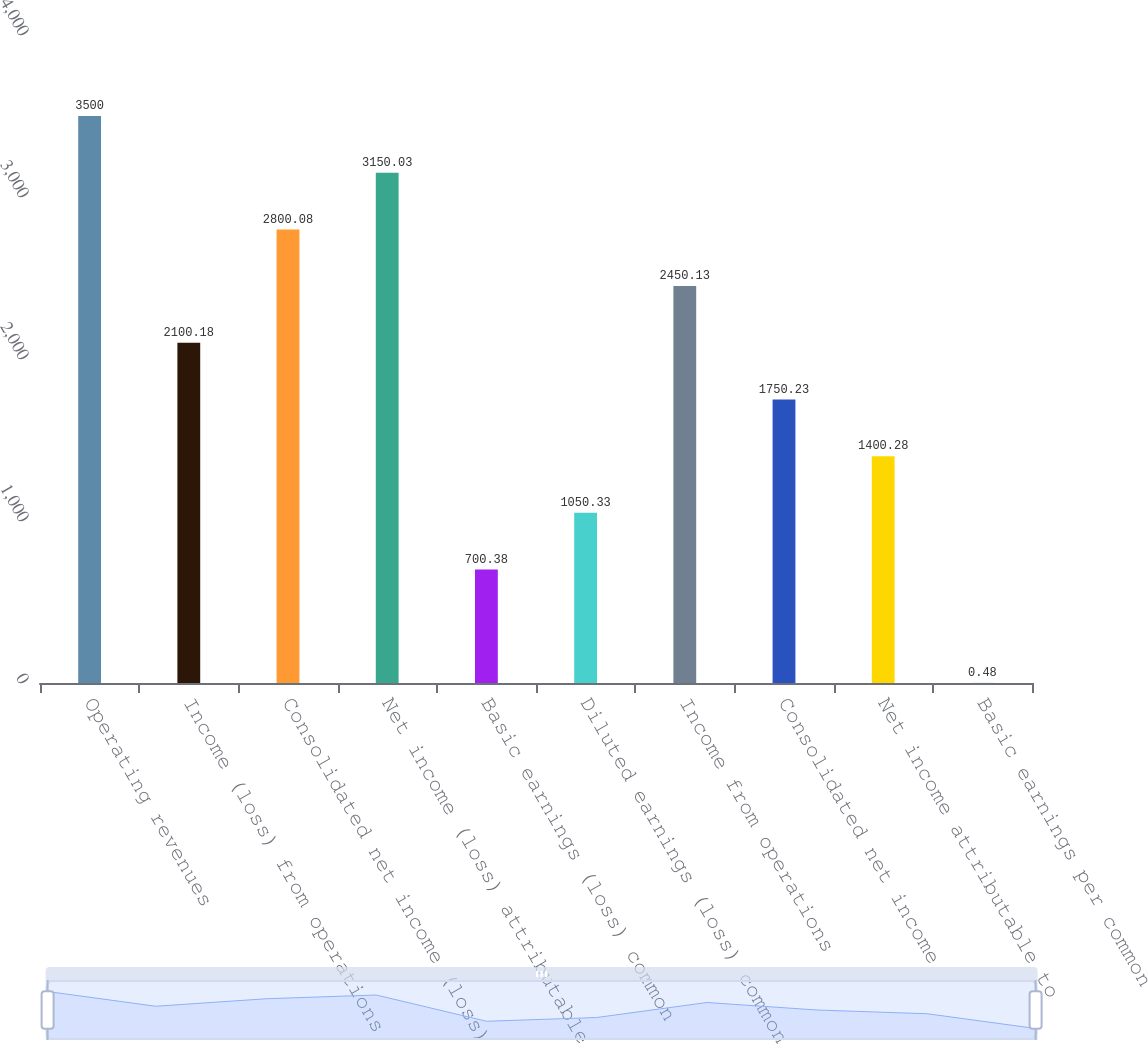Convert chart to OTSL. <chart><loc_0><loc_0><loc_500><loc_500><bar_chart><fcel>Operating revenues<fcel>Income (loss) from operations<fcel>Consolidated net income (loss)<fcel>Net income (loss) attributable<fcel>Basic earnings (loss) common<fcel>Diluted earnings (loss) common<fcel>Income from operations<fcel>Consolidated net income<fcel>Net income attributable to<fcel>Basic earnings per common<nl><fcel>3500<fcel>2100.18<fcel>2800.08<fcel>3150.03<fcel>700.38<fcel>1050.33<fcel>2450.13<fcel>1750.23<fcel>1400.28<fcel>0.48<nl></chart> 